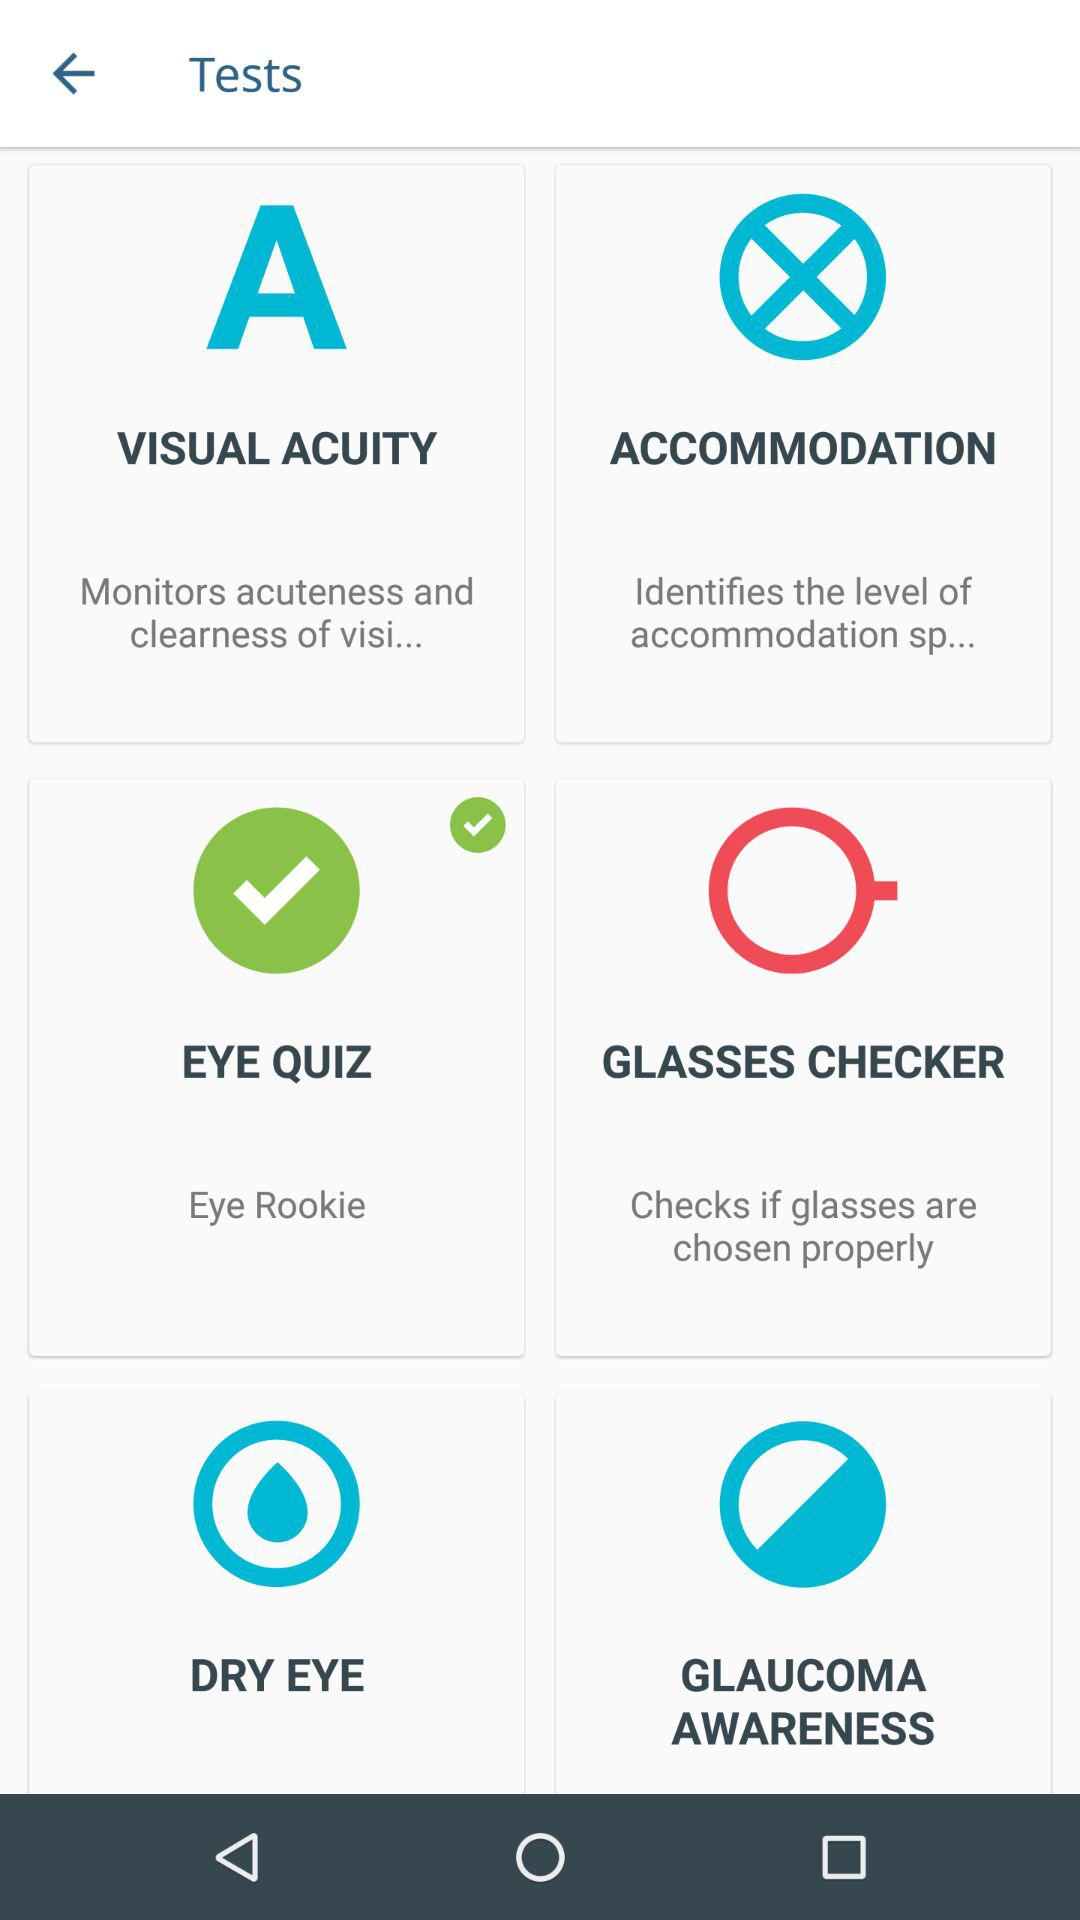How many tests are available in the first row?
Answer the question using a single word or phrase. 2 